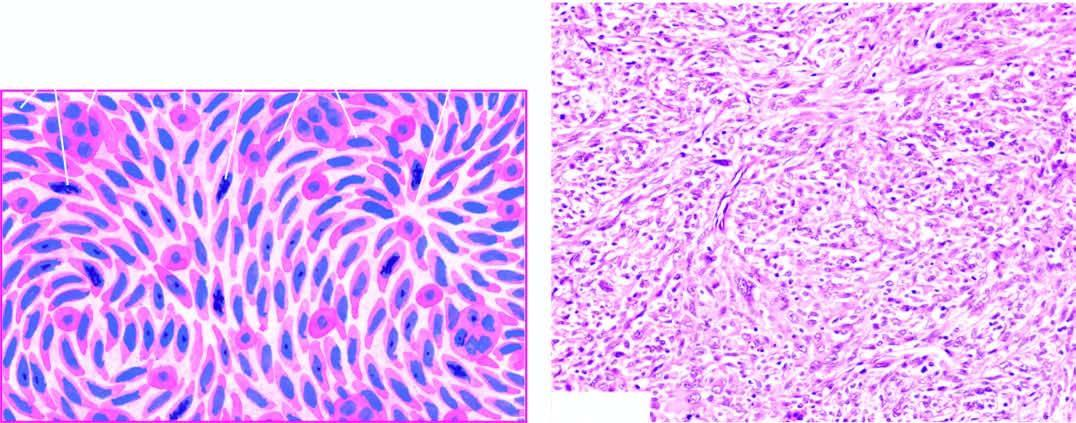what shows admixture of spindle-shaped pleomorphic cells forming storiform pattern and histiocyte-like round to oval cells?
Answer the question using a single word or phrase. Tumour 